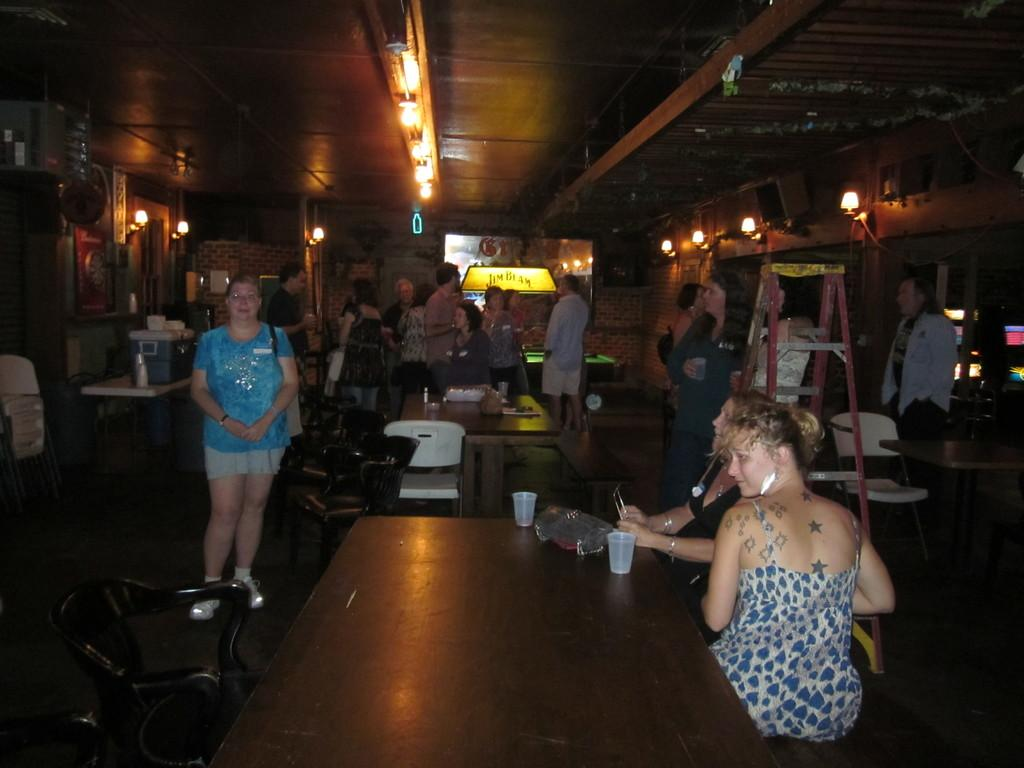What are the people in the image doing? There are people sitting on a bench and standing in the image. What objects can be seen in the image besides the people? There is a table, a glass, and a laptop on the table. Where is the glass located in the image? The glass is on the table in the image. What might the people be using the laptop for? It is not clear from the image what the people might be using the laptop for. What type of idea is being discussed by the family in the image? There is no mention of a family or an idea being discussed in the image. 